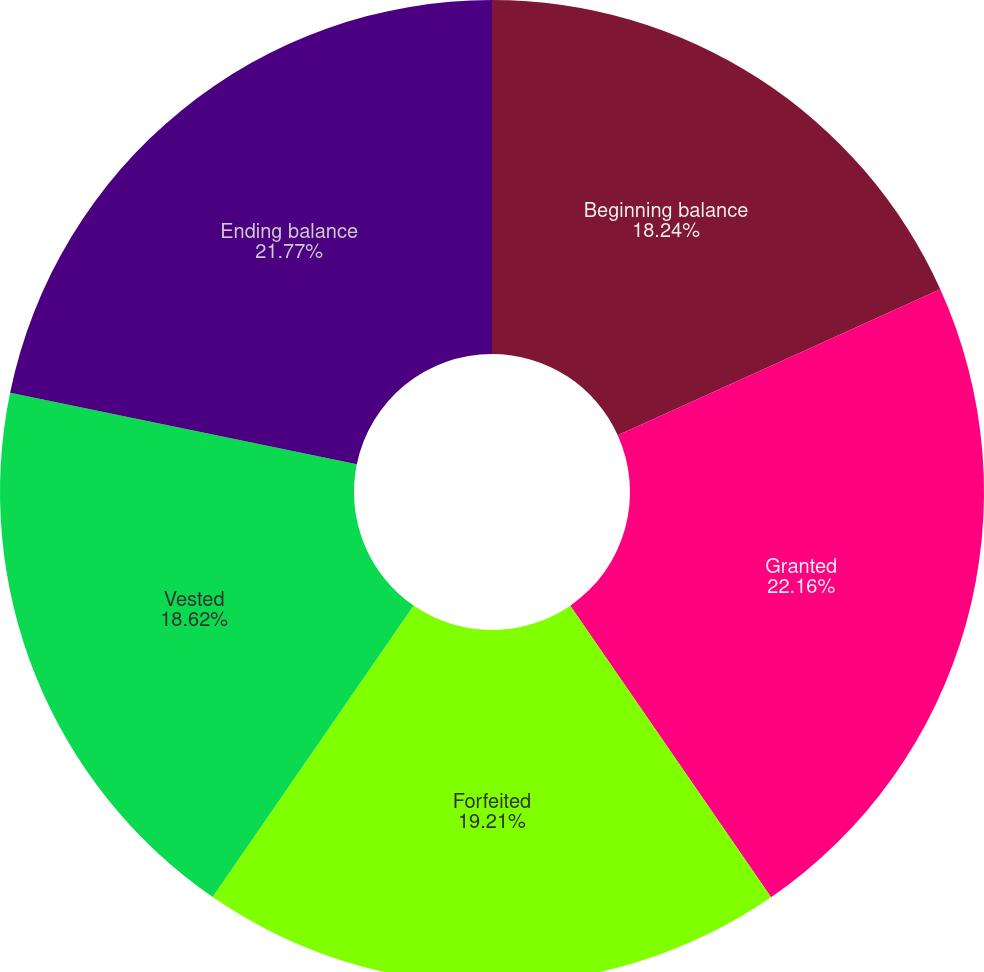Convert chart. <chart><loc_0><loc_0><loc_500><loc_500><pie_chart><fcel>Beginning balance<fcel>Granted<fcel>Forfeited<fcel>Vested<fcel>Ending balance<nl><fcel>18.24%<fcel>22.16%<fcel>19.21%<fcel>18.62%<fcel>21.77%<nl></chart> 